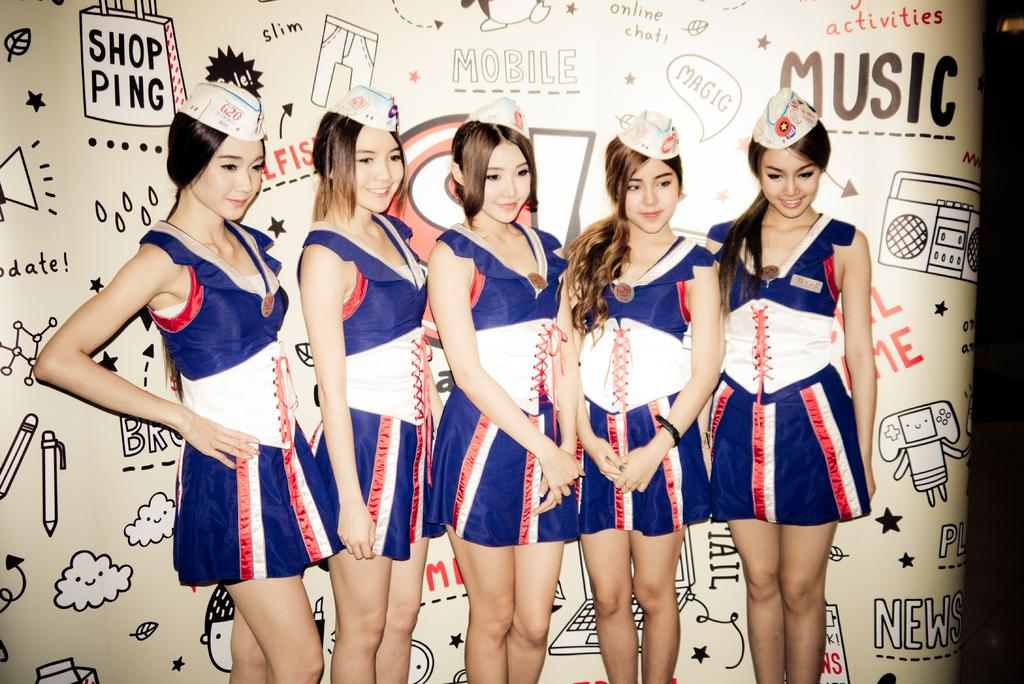<image>
Give a short and clear explanation of the subsequent image. Five young women stand in front of a display which contains the word music 